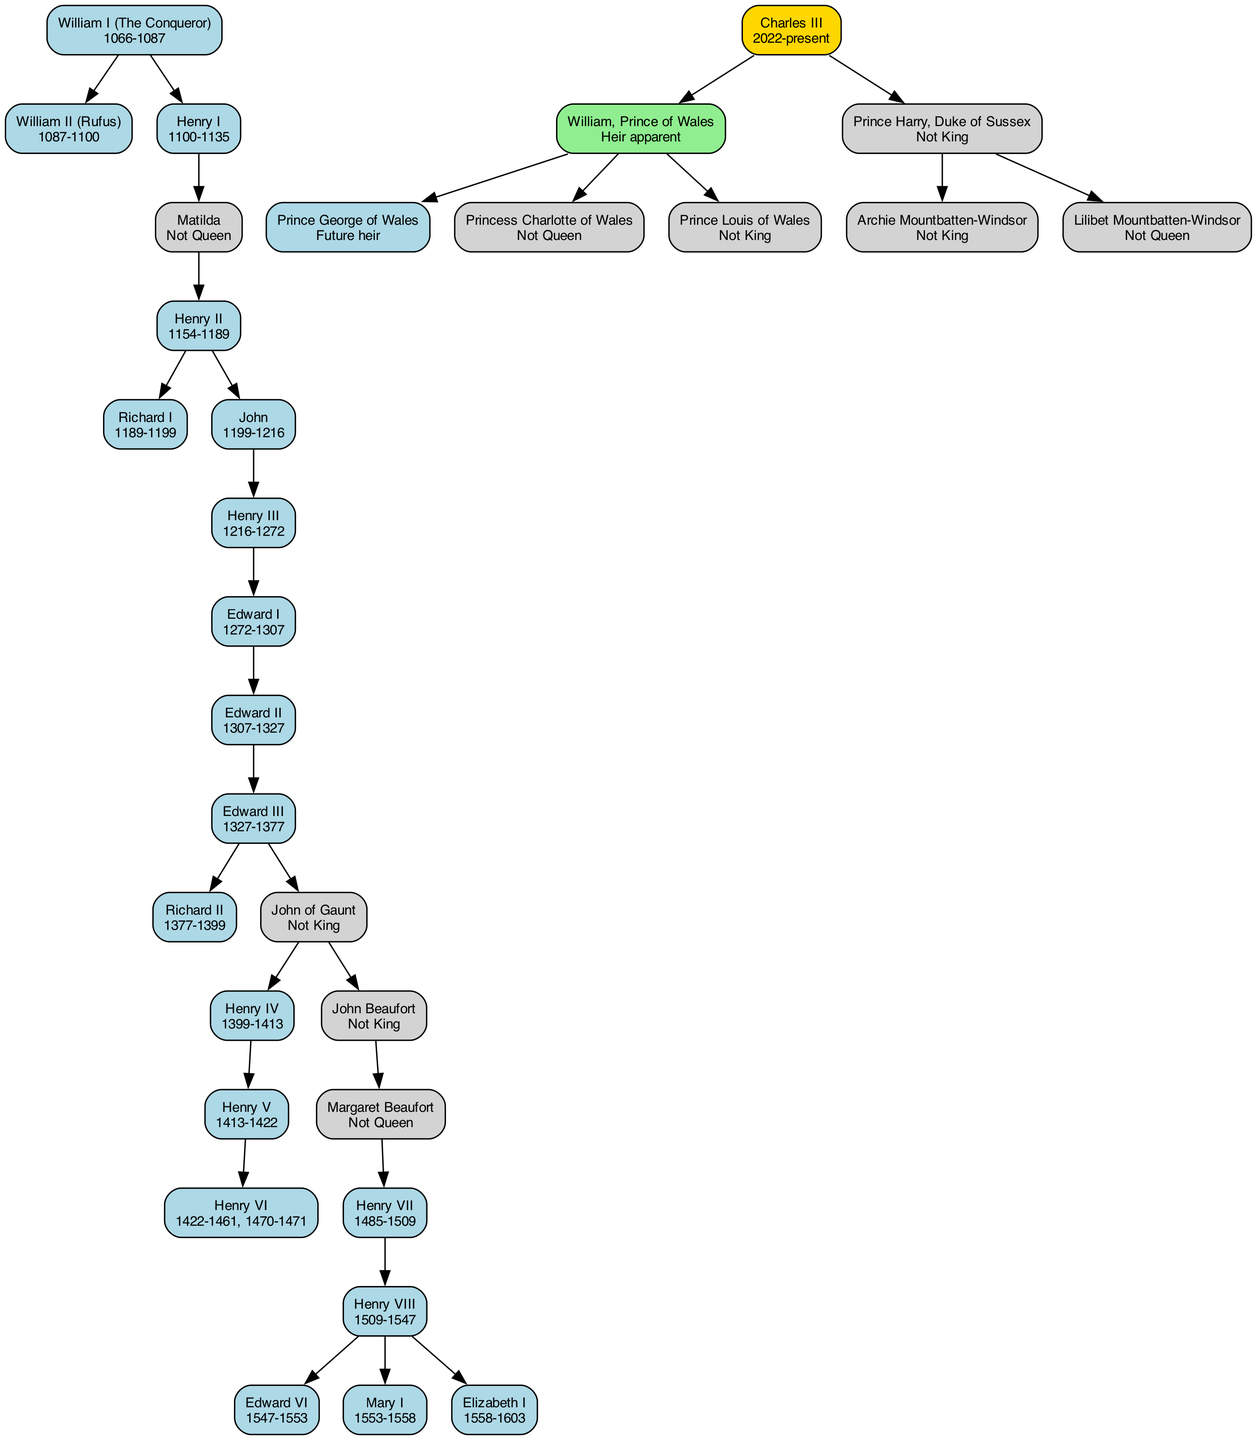What is the reign of Henry VIII? The diagram indicates that Henry VIII reigned from 1509 to 1547. This can be found directly under his name in the node representing him.
Answer: 1509-1547 Who was the parent of Edward III? Examining the diagram, whether through the direct lineage or by tracing back the "children" nodes, it is clear that Edward III's father is Edward II. This is evident by following the lines from Edward III to Edward II.
Answer: Edward II How many children does Charles III have? Looking at the current royal family section of the diagram, we can count that there are two children listed under Charles III's node: William, Prince of Wales, and Prince Harry. Adding them gives us a total of two children.
Answer: 2 Who ruled immediately after Richard II? To answer this, we trace from Richard II, whose node leads to no children directly and goes to John of Gaunt, leading to Henry IV. Therefore, the immediate successor to Richard II is Henry IV.
Answer: Henry IV How many generations are between William I and Charles III? Starting from William I, we can count the ancestors down to Charles III. The generations are: William I to Henry I (1), Henry I to Matilda (2), Matilda to Henry II (3), Henry II to Edward III (4), Edward III to Henry VI (5), Henry VI to Henry VII (6), Henry VII to Henry VIII (7), and then to Edward VI, Mary I, Elizabeth I (8), and finally to Charles III, marking 9 generations in total.
Answer: 9 What status does Princess Charlotte of Wales hold? In the family tree representation, Princess Charlotte of Wales is explicitly labeled with the status of "Not Queen," which can be verified in her respective node.
Answer: Not Queen Who was the monarch between Henry V and Henry VI? Tracing the timeline on the diagram, we see that there are only two monarchs listed consecutively during that period: Henry V and then immediately followed by Henry VI. Hence, there was no monarch in between; just a direct succession.
Answer: None How many children does John Beaufort have? By inspecting John Beaufort's node in the diagram, we find that he has one child, Margaret Beaufort, indicating that the total is just one child listed under his lineage.
Answer: 1 